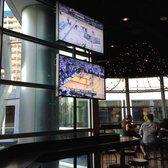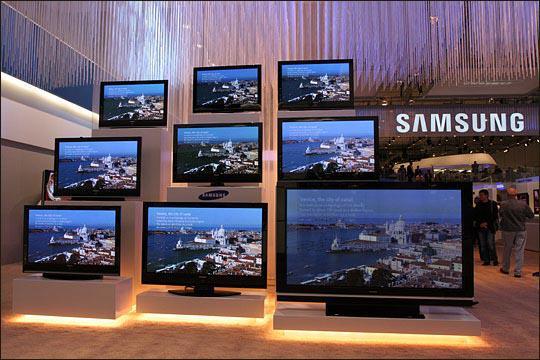The first image is the image on the left, the second image is the image on the right. Analyze the images presented: Is the assertion "Someone is watching TV white sitting on a couch in the right image." valid? Answer yes or no. No. The first image is the image on the left, the second image is the image on the right. Evaluate the accuracy of this statement regarding the images: "There is only one tv in each image". Is it true? Answer yes or no. No. 